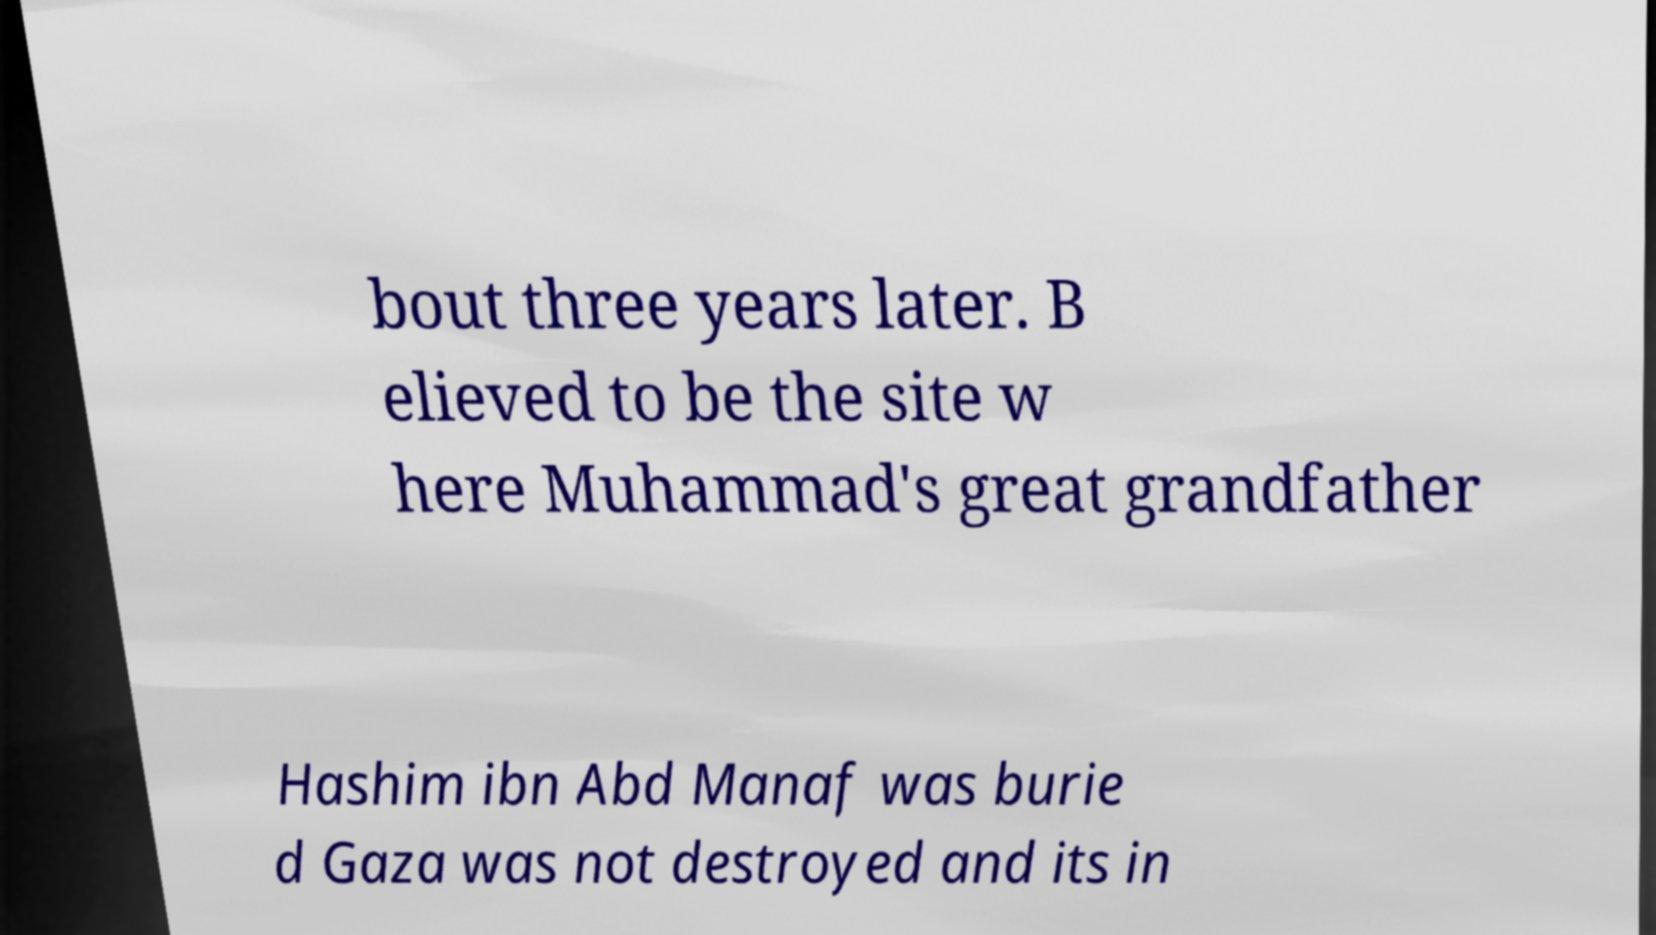Please read and relay the text visible in this image. What does it say? bout three years later. B elieved to be the site w here Muhammad's great grandfather Hashim ibn Abd Manaf was burie d Gaza was not destroyed and its in 